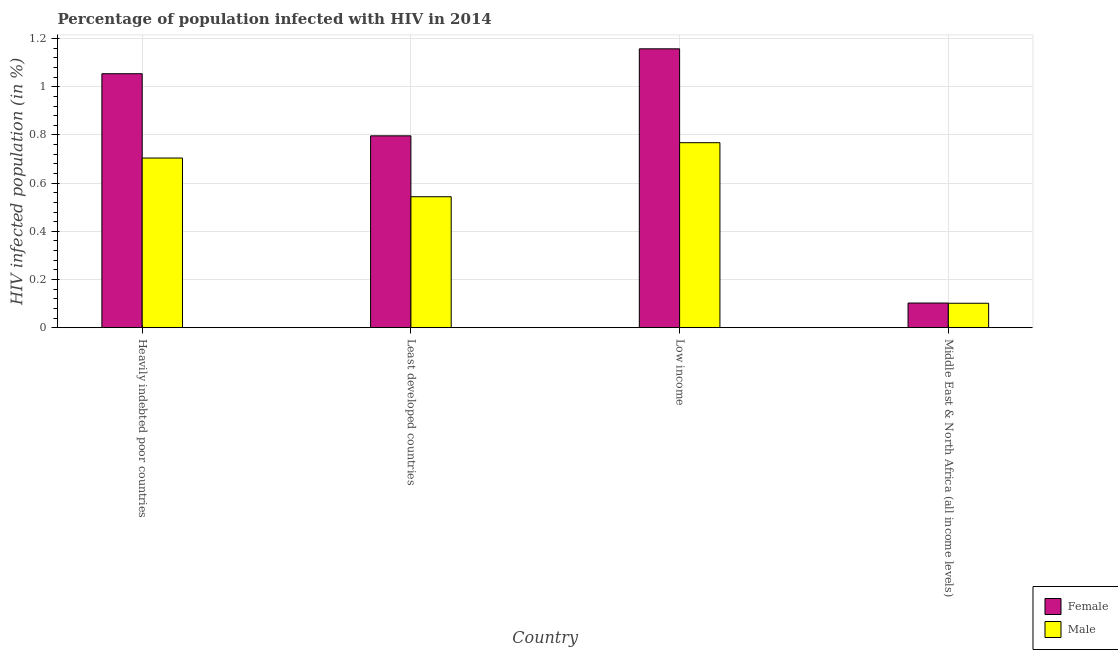How many groups of bars are there?
Provide a short and direct response. 4. Are the number of bars on each tick of the X-axis equal?
Offer a terse response. Yes. How many bars are there on the 4th tick from the left?
Offer a very short reply. 2. What is the label of the 4th group of bars from the left?
Your answer should be compact. Middle East & North Africa (all income levels). In how many cases, is the number of bars for a given country not equal to the number of legend labels?
Ensure brevity in your answer.  0. What is the percentage of males who are infected with hiv in Least developed countries?
Ensure brevity in your answer.  0.54. Across all countries, what is the maximum percentage of females who are infected with hiv?
Give a very brief answer. 1.16. Across all countries, what is the minimum percentage of males who are infected with hiv?
Provide a succinct answer. 0.1. In which country was the percentage of males who are infected with hiv minimum?
Offer a terse response. Middle East & North Africa (all income levels). What is the total percentage of males who are infected with hiv in the graph?
Provide a succinct answer. 2.12. What is the difference between the percentage of females who are infected with hiv in Low income and that in Middle East & North Africa (all income levels)?
Provide a succinct answer. 1.06. What is the difference between the percentage of males who are infected with hiv in Heavily indebted poor countries and the percentage of females who are infected with hiv in Middle East & North Africa (all income levels)?
Offer a very short reply. 0.6. What is the average percentage of females who are infected with hiv per country?
Give a very brief answer. 0.78. What is the difference between the percentage of males who are infected with hiv and percentage of females who are infected with hiv in Least developed countries?
Your answer should be very brief. -0.25. What is the ratio of the percentage of females who are infected with hiv in Heavily indebted poor countries to that in Least developed countries?
Provide a succinct answer. 1.32. Is the difference between the percentage of males who are infected with hiv in Heavily indebted poor countries and Least developed countries greater than the difference between the percentage of females who are infected with hiv in Heavily indebted poor countries and Least developed countries?
Give a very brief answer. No. What is the difference between the highest and the second highest percentage of males who are infected with hiv?
Offer a very short reply. 0.06. What is the difference between the highest and the lowest percentage of males who are infected with hiv?
Ensure brevity in your answer.  0.67. In how many countries, is the percentage of females who are infected with hiv greater than the average percentage of females who are infected with hiv taken over all countries?
Offer a terse response. 3. Are all the bars in the graph horizontal?
Your answer should be very brief. No. Are the values on the major ticks of Y-axis written in scientific E-notation?
Keep it short and to the point. No. Does the graph contain any zero values?
Your answer should be very brief. No. Does the graph contain grids?
Ensure brevity in your answer.  Yes. How many legend labels are there?
Your response must be concise. 2. How are the legend labels stacked?
Ensure brevity in your answer.  Vertical. What is the title of the graph?
Your answer should be compact. Percentage of population infected with HIV in 2014. Does "Long-term debt" appear as one of the legend labels in the graph?
Offer a very short reply. No. What is the label or title of the Y-axis?
Your response must be concise. HIV infected population (in %). What is the HIV infected population (in %) in Female in Heavily indebted poor countries?
Give a very brief answer. 1.05. What is the HIV infected population (in %) in Male in Heavily indebted poor countries?
Your response must be concise. 0.7. What is the HIV infected population (in %) in Female in Least developed countries?
Provide a short and direct response. 0.8. What is the HIV infected population (in %) in Male in Least developed countries?
Ensure brevity in your answer.  0.54. What is the HIV infected population (in %) in Female in Low income?
Make the answer very short. 1.16. What is the HIV infected population (in %) of Male in Low income?
Your answer should be compact. 0.77. What is the HIV infected population (in %) in Female in Middle East & North Africa (all income levels)?
Give a very brief answer. 0.1. What is the HIV infected population (in %) in Male in Middle East & North Africa (all income levels)?
Your response must be concise. 0.1. Across all countries, what is the maximum HIV infected population (in %) in Female?
Give a very brief answer. 1.16. Across all countries, what is the maximum HIV infected population (in %) in Male?
Make the answer very short. 0.77. Across all countries, what is the minimum HIV infected population (in %) of Female?
Offer a terse response. 0.1. Across all countries, what is the minimum HIV infected population (in %) of Male?
Make the answer very short. 0.1. What is the total HIV infected population (in %) of Female in the graph?
Your response must be concise. 3.11. What is the total HIV infected population (in %) of Male in the graph?
Your answer should be compact. 2.12. What is the difference between the HIV infected population (in %) in Female in Heavily indebted poor countries and that in Least developed countries?
Keep it short and to the point. 0.26. What is the difference between the HIV infected population (in %) in Male in Heavily indebted poor countries and that in Least developed countries?
Give a very brief answer. 0.16. What is the difference between the HIV infected population (in %) in Female in Heavily indebted poor countries and that in Low income?
Your answer should be compact. -0.1. What is the difference between the HIV infected population (in %) of Male in Heavily indebted poor countries and that in Low income?
Make the answer very short. -0.06. What is the difference between the HIV infected population (in %) of Female in Heavily indebted poor countries and that in Middle East & North Africa (all income levels)?
Ensure brevity in your answer.  0.95. What is the difference between the HIV infected population (in %) in Male in Heavily indebted poor countries and that in Middle East & North Africa (all income levels)?
Provide a succinct answer. 0.6. What is the difference between the HIV infected population (in %) in Female in Least developed countries and that in Low income?
Offer a terse response. -0.36. What is the difference between the HIV infected population (in %) in Male in Least developed countries and that in Low income?
Your answer should be compact. -0.22. What is the difference between the HIV infected population (in %) of Female in Least developed countries and that in Middle East & North Africa (all income levels)?
Keep it short and to the point. 0.69. What is the difference between the HIV infected population (in %) of Male in Least developed countries and that in Middle East & North Africa (all income levels)?
Your answer should be compact. 0.44. What is the difference between the HIV infected population (in %) of Female in Low income and that in Middle East & North Africa (all income levels)?
Your answer should be compact. 1.06. What is the difference between the HIV infected population (in %) in Male in Low income and that in Middle East & North Africa (all income levels)?
Your response must be concise. 0.67. What is the difference between the HIV infected population (in %) of Female in Heavily indebted poor countries and the HIV infected population (in %) of Male in Least developed countries?
Ensure brevity in your answer.  0.51. What is the difference between the HIV infected population (in %) of Female in Heavily indebted poor countries and the HIV infected population (in %) of Male in Low income?
Provide a short and direct response. 0.29. What is the difference between the HIV infected population (in %) in Female in Heavily indebted poor countries and the HIV infected population (in %) in Male in Middle East & North Africa (all income levels)?
Make the answer very short. 0.95. What is the difference between the HIV infected population (in %) of Female in Least developed countries and the HIV infected population (in %) of Male in Low income?
Make the answer very short. 0.03. What is the difference between the HIV infected population (in %) in Female in Least developed countries and the HIV infected population (in %) in Male in Middle East & North Africa (all income levels)?
Give a very brief answer. 0.69. What is the difference between the HIV infected population (in %) in Female in Low income and the HIV infected population (in %) in Male in Middle East & North Africa (all income levels)?
Your answer should be very brief. 1.06. What is the average HIV infected population (in %) in Female per country?
Give a very brief answer. 0.78. What is the average HIV infected population (in %) in Male per country?
Offer a terse response. 0.53. What is the difference between the HIV infected population (in %) in Female and HIV infected population (in %) in Male in Heavily indebted poor countries?
Keep it short and to the point. 0.35. What is the difference between the HIV infected population (in %) in Female and HIV infected population (in %) in Male in Least developed countries?
Your response must be concise. 0.25. What is the difference between the HIV infected population (in %) in Female and HIV infected population (in %) in Male in Low income?
Provide a succinct answer. 0.39. What is the ratio of the HIV infected population (in %) of Female in Heavily indebted poor countries to that in Least developed countries?
Offer a very short reply. 1.32. What is the ratio of the HIV infected population (in %) in Male in Heavily indebted poor countries to that in Least developed countries?
Your answer should be compact. 1.3. What is the ratio of the HIV infected population (in %) of Female in Heavily indebted poor countries to that in Low income?
Your response must be concise. 0.91. What is the ratio of the HIV infected population (in %) of Male in Heavily indebted poor countries to that in Low income?
Your answer should be very brief. 0.92. What is the ratio of the HIV infected population (in %) of Female in Heavily indebted poor countries to that in Middle East & North Africa (all income levels)?
Provide a short and direct response. 10.3. What is the ratio of the HIV infected population (in %) of Male in Heavily indebted poor countries to that in Middle East & North Africa (all income levels)?
Offer a very short reply. 6.95. What is the ratio of the HIV infected population (in %) of Female in Least developed countries to that in Low income?
Keep it short and to the point. 0.69. What is the ratio of the HIV infected population (in %) of Male in Least developed countries to that in Low income?
Provide a short and direct response. 0.71. What is the ratio of the HIV infected population (in %) of Female in Least developed countries to that in Middle East & North Africa (all income levels)?
Offer a terse response. 7.78. What is the ratio of the HIV infected population (in %) of Male in Least developed countries to that in Middle East & North Africa (all income levels)?
Your answer should be compact. 5.37. What is the ratio of the HIV infected population (in %) in Female in Low income to that in Middle East & North Africa (all income levels)?
Offer a very short reply. 11.31. What is the ratio of the HIV infected population (in %) of Male in Low income to that in Middle East & North Africa (all income levels)?
Your answer should be very brief. 7.58. What is the difference between the highest and the second highest HIV infected population (in %) of Female?
Your response must be concise. 0.1. What is the difference between the highest and the second highest HIV infected population (in %) in Male?
Ensure brevity in your answer.  0.06. What is the difference between the highest and the lowest HIV infected population (in %) of Female?
Offer a terse response. 1.06. What is the difference between the highest and the lowest HIV infected population (in %) in Male?
Your response must be concise. 0.67. 